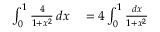<formula> <loc_0><loc_0><loc_500><loc_500>\begin{array} { r l } { \int _ { 0 } ^ { 1 } { \frac { 4 } { 1 + x ^ { 2 } } } \, d x } & = 4 \int _ { 0 } ^ { 1 } { \frac { d x } { 1 + x ^ { 2 } } } } \end{array}</formula> 